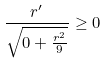<formula> <loc_0><loc_0><loc_500><loc_500>\frac { r ^ { \prime } } { \sqrt { 0 + \frac { r ^ { 2 } } { 9 } } } \geq 0</formula> 